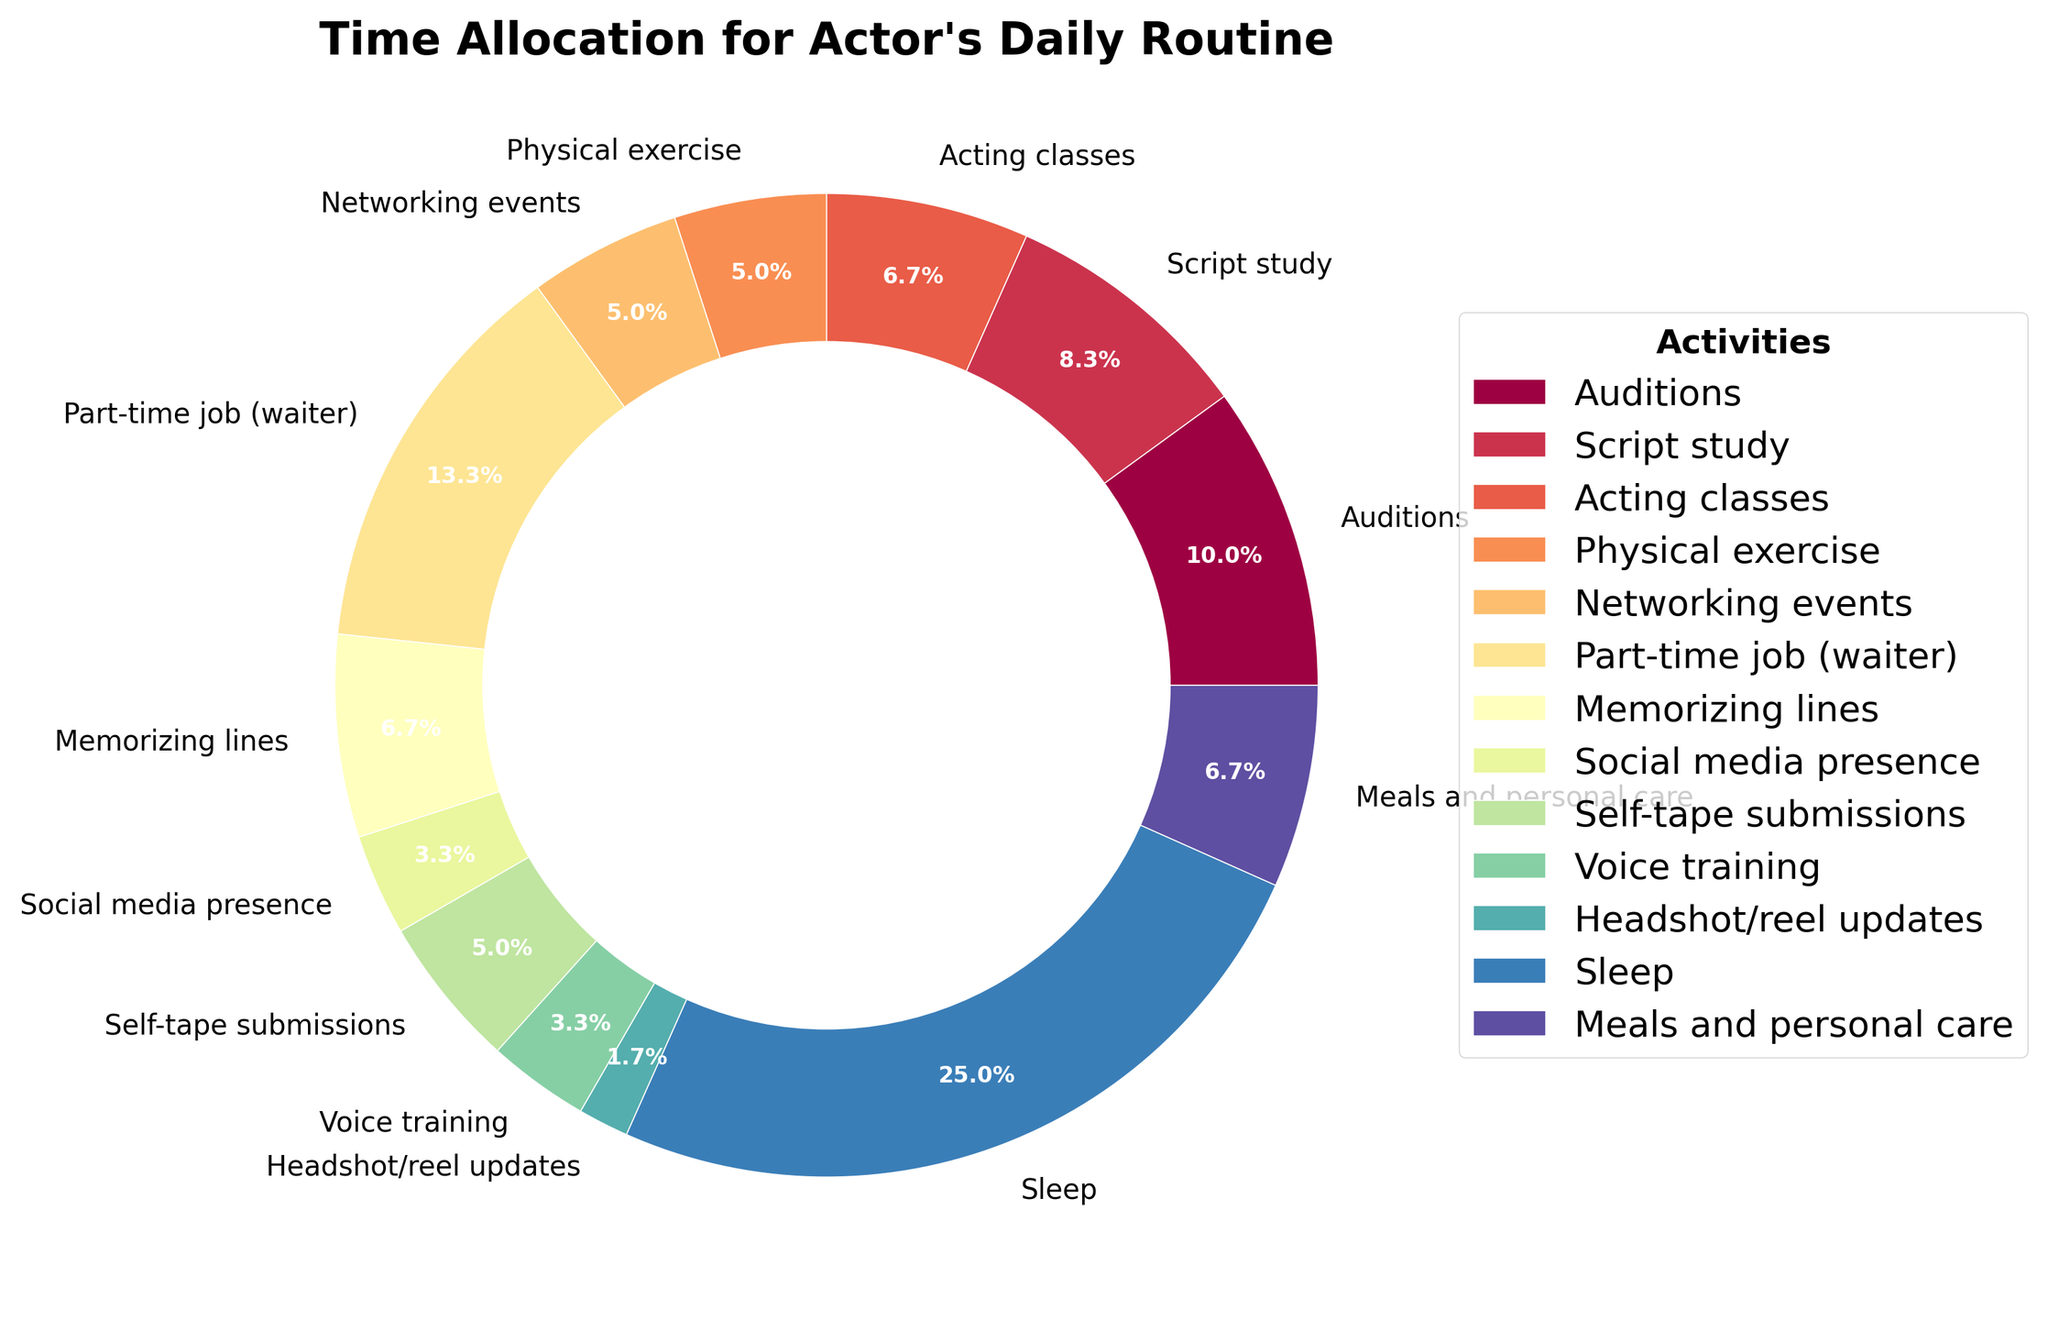what activity takes up the largest portion of an actor's daily routine? By looking at the pie chart, we can see that "Sleep" has the largest wedge. According to the data, sleep takes up 7.5 hours, which is the largest portion.
Answer: Sleep How many hours are spent on physical exercise and voice training combined? The time spent on physical exercise is 1.5 hours, and on voice training is 1 hour. Adding them up gives 1.5 + 1 = 2.5 hours.
Answer: 2.5 hours Which activity takes up more time, script study or acting classes? By comparing the wedges for script study and acting classes, we see that script study (2.5 hours) takes more time than acting classes (2 hours).
Answer: Script study What percentage of the day is dedicated to networking events and self-tape submissions combined? The time spent on networking events is 1.5 hours, and on self-tape submissions is 1.5 hours. The total combined is 3 hours out of a 24-hour day. To convert this to percentage: (3/24) * 100 = 12.5%.
Answer: 12.5% Which activity has the smallest portion in the actor's daily routine? From the pie chart, the "Headshot/reel updates" wedge appears to be the smallest. According to the data, this activity takes up only 0.5 hours.
Answer: Headshot/reel updates Is more time spent on sleep or all work-related activities combined (auditions, part-time job, script study, acting classes, networking events, memorizing lines, self-tape submissions, voice training, and headshot/reel updates)? First, calculate the total time spent on all work-related activities: 3 (auditions) + 4 (part-time job) + 2.5 (script study) + 2 (acting classes) + 1.5 (networking events) + 2 (memorizing lines) + 1.5 (self-tape submissions) + 1 (voice training) + 0.5 (headshot/reel updates) = 18 hours. Since sleep is 7.5 hours, more time is spent on all work-related activities combined.
Answer: All work-related activities combined How many hours are spent on meals and personal care, and social media presence together? The time spent on meals and personal care is 2 hours, and on social media presence is 1 hour. Adding them together gives 2 + 1 = 3 hours.
Answer: 3 hours Is the time spent in networking events equal to the time spent in self-tape submissions? According to the data, both networking events and self-tape submissions take 1.5 hours each.
Answer: Yes Which takes up more time, memorizing lines or physical exercise? The time for memorizing lines is 2 hours, while physical exercise is 1.5 hours. Memorizing lines takes more time.
Answer: Memorizing lines How much more or less time is spent on voice training compared to headshot/reel updates? The time spent on voice training is 1 hour, and headshot/reel updates is 0.5 hours. The difference is 1 - 0.5 = 0.5 hours.
Answer: 0.5 hours more 